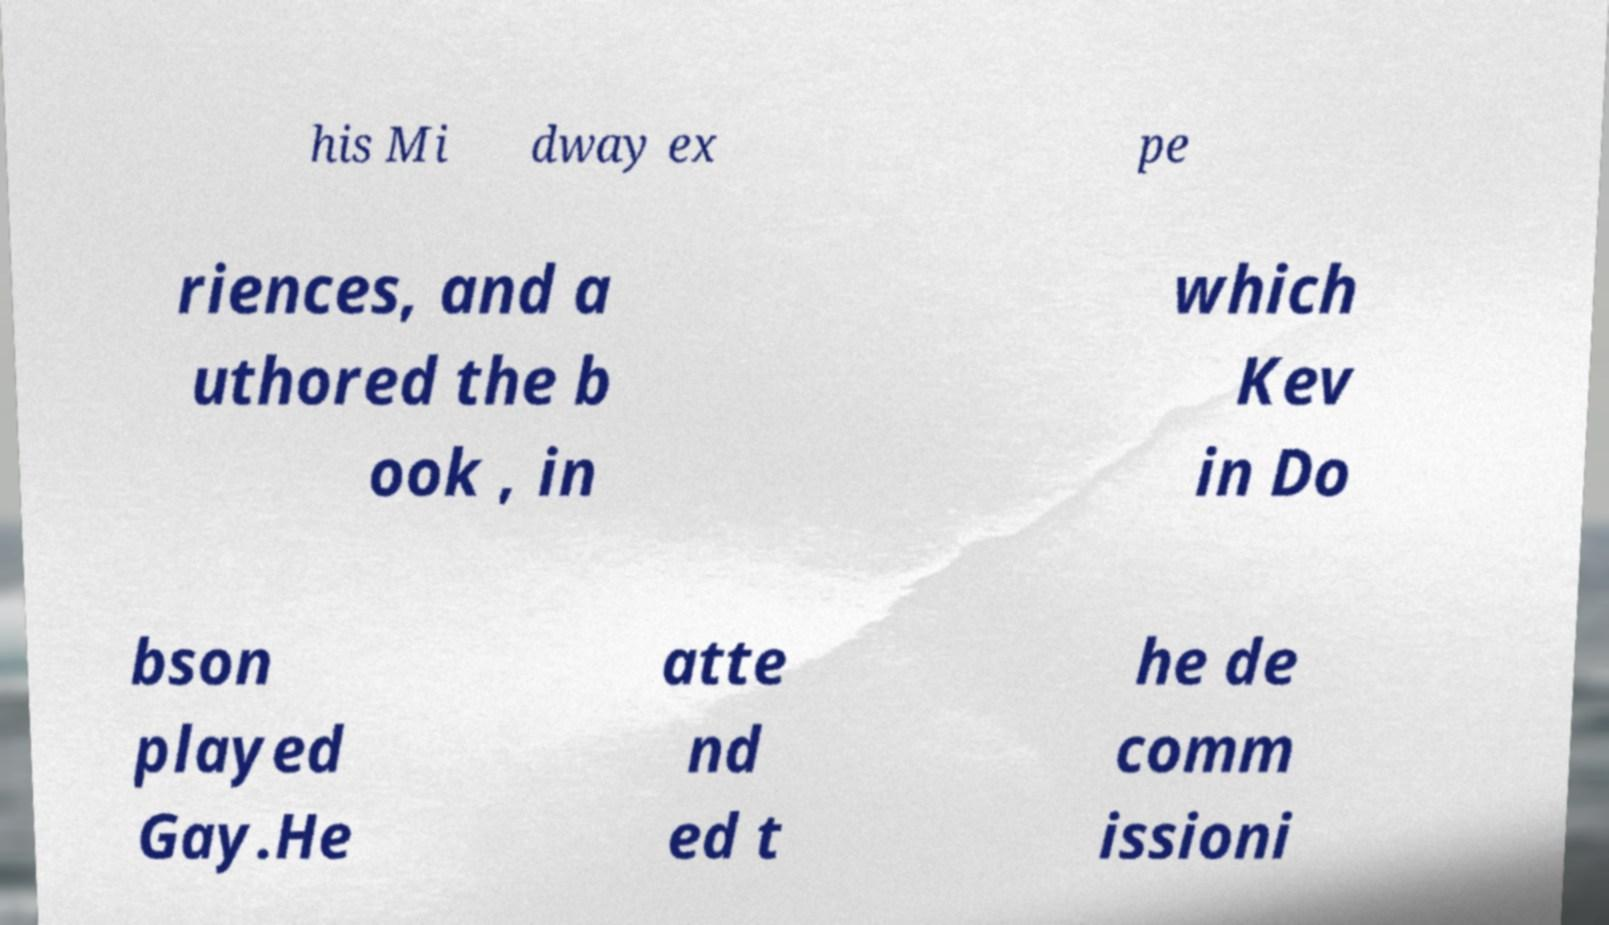There's text embedded in this image that I need extracted. Can you transcribe it verbatim? his Mi dway ex pe riences, and a uthored the b ook , in which Kev in Do bson played Gay.He atte nd ed t he de comm issioni 